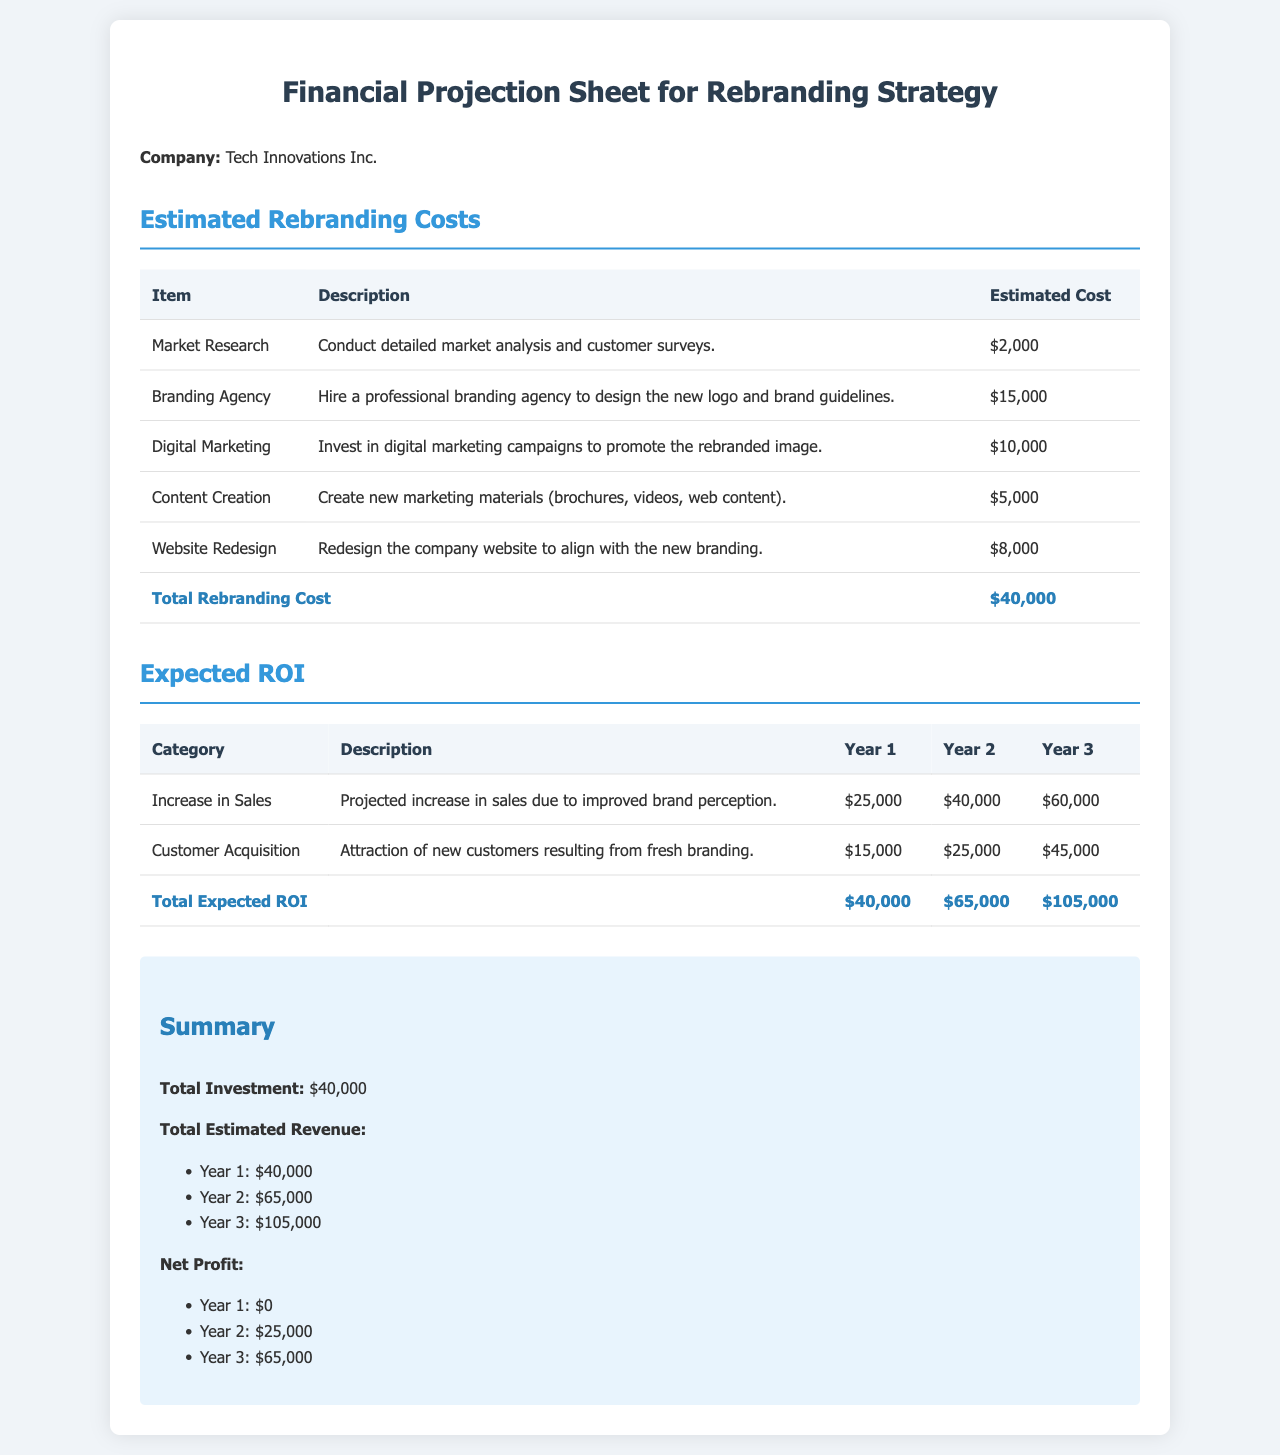What is the total estimated cost for rebranding? The total estimated cost is clearly stated at the bottom of the rebranding costs table.
Answer: $40,000 What is the expected increase in sales in Year 3? This value is found in the expected ROI table under the Increase in Sales row for Year 3.
Answer: $60,000 How much is allocated for digital marketing? The amount for digital marketing is listed in the estimated rebranding costs section.
Answer: $10,000 What is the net profit in Year 2? The net profit is calculated from total revenue minus total investment for Year 2 as shown in the summary section.
Answer: $25,000 Who is the company undertaking the rebranding? The document provides the company name at the top in the company line.
Answer: Tech Innovations Inc What is the estimated cost for website redesign? The document includes specific costs for each item in the estimated costs section.
Answer: $8,000 What category does customer acquisition fall under in the expected ROI? The expected ROI table categorizes customer acquisition separately under its own row.
Answer: Customer Acquisition What is the total estimated revenue in Year 1? This is provided in the summary section alongside total investment.
Answer: $40,000 How many years are projected for this financial analysis? The expected ROI table outlines projections for sales and customer acquisition over a span of three years.
Answer: 3 years 